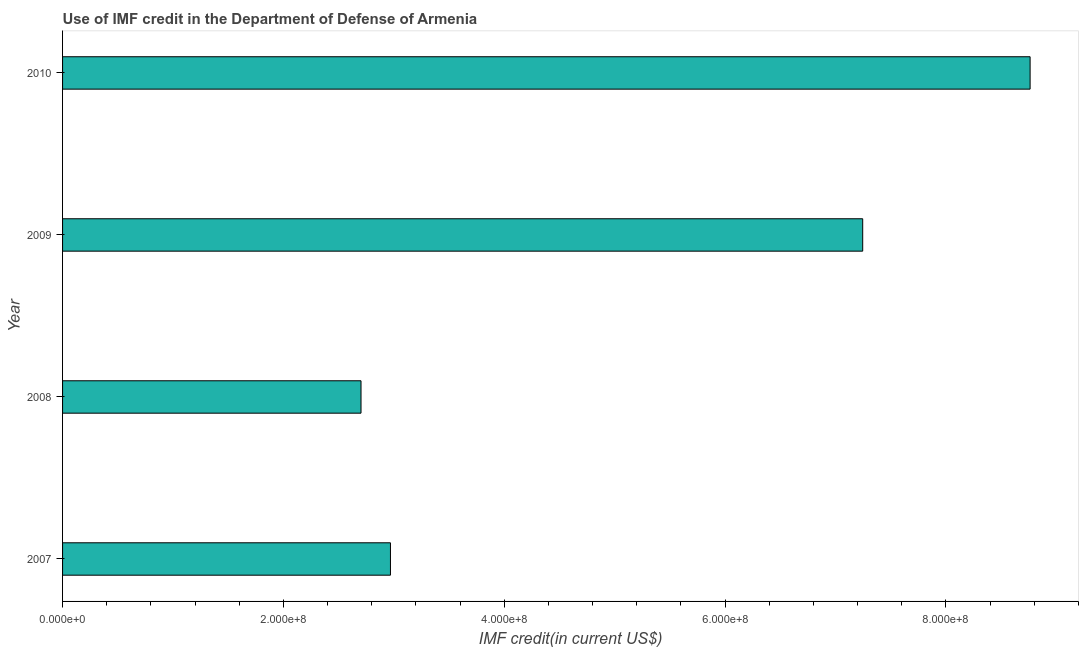What is the title of the graph?
Your answer should be compact. Use of IMF credit in the Department of Defense of Armenia. What is the label or title of the X-axis?
Your response must be concise. IMF credit(in current US$). What is the label or title of the Y-axis?
Provide a short and direct response. Year. What is the use of imf credit in dod in 2007?
Give a very brief answer. 2.97e+08. Across all years, what is the maximum use of imf credit in dod?
Make the answer very short. 8.76e+08. Across all years, what is the minimum use of imf credit in dod?
Your answer should be compact. 2.70e+08. In which year was the use of imf credit in dod minimum?
Your response must be concise. 2008. What is the sum of the use of imf credit in dod?
Keep it short and to the point. 2.17e+09. What is the difference between the use of imf credit in dod in 2008 and 2010?
Provide a short and direct response. -6.06e+08. What is the average use of imf credit in dod per year?
Your answer should be compact. 5.42e+08. What is the median use of imf credit in dod?
Give a very brief answer. 5.11e+08. In how many years, is the use of imf credit in dod greater than 280000000 US$?
Provide a succinct answer. 3. Do a majority of the years between 2008 and 2009 (inclusive) have use of imf credit in dod greater than 640000000 US$?
Offer a terse response. No. What is the ratio of the use of imf credit in dod in 2007 to that in 2009?
Offer a very short reply. 0.41. Is the use of imf credit in dod in 2008 less than that in 2009?
Give a very brief answer. Yes. What is the difference between the highest and the second highest use of imf credit in dod?
Your response must be concise. 1.52e+08. Is the sum of the use of imf credit in dod in 2008 and 2009 greater than the maximum use of imf credit in dod across all years?
Ensure brevity in your answer.  Yes. What is the difference between the highest and the lowest use of imf credit in dod?
Give a very brief answer. 6.06e+08. In how many years, is the use of imf credit in dod greater than the average use of imf credit in dod taken over all years?
Make the answer very short. 2. How many bars are there?
Keep it short and to the point. 4. Are all the bars in the graph horizontal?
Ensure brevity in your answer.  Yes. Are the values on the major ticks of X-axis written in scientific E-notation?
Provide a short and direct response. Yes. What is the IMF credit(in current US$) in 2007?
Your response must be concise. 2.97e+08. What is the IMF credit(in current US$) of 2008?
Make the answer very short. 2.70e+08. What is the IMF credit(in current US$) of 2009?
Offer a terse response. 7.25e+08. What is the IMF credit(in current US$) in 2010?
Keep it short and to the point. 8.76e+08. What is the difference between the IMF credit(in current US$) in 2007 and 2008?
Provide a succinct answer. 2.67e+07. What is the difference between the IMF credit(in current US$) in 2007 and 2009?
Give a very brief answer. -4.28e+08. What is the difference between the IMF credit(in current US$) in 2007 and 2010?
Ensure brevity in your answer.  -5.79e+08. What is the difference between the IMF credit(in current US$) in 2008 and 2009?
Provide a short and direct response. -4.54e+08. What is the difference between the IMF credit(in current US$) in 2008 and 2010?
Provide a short and direct response. -6.06e+08. What is the difference between the IMF credit(in current US$) in 2009 and 2010?
Keep it short and to the point. -1.52e+08. What is the ratio of the IMF credit(in current US$) in 2007 to that in 2008?
Offer a terse response. 1.1. What is the ratio of the IMF credit(in current US$) in 2007 to that in 2009?
Keep it short and to the point. 0.41. What is the ratio of the IMF credit(in current US$) in 2007 to that in 2010?
Provide a short and direct response. 0.34. What is the ratio of the IMF credit(in current US$) in 2008 to that in 2009?
Provide a short and direct response. 0.37. What is the ratio of the IMF credit(in current US$) in 2008 to that in 2010?
Keep it short and to the point. 0.31. What is the ratio of the IMF credit(in current US$) in 2009 to that in 2010?
Your response must be concise. 0.83. 